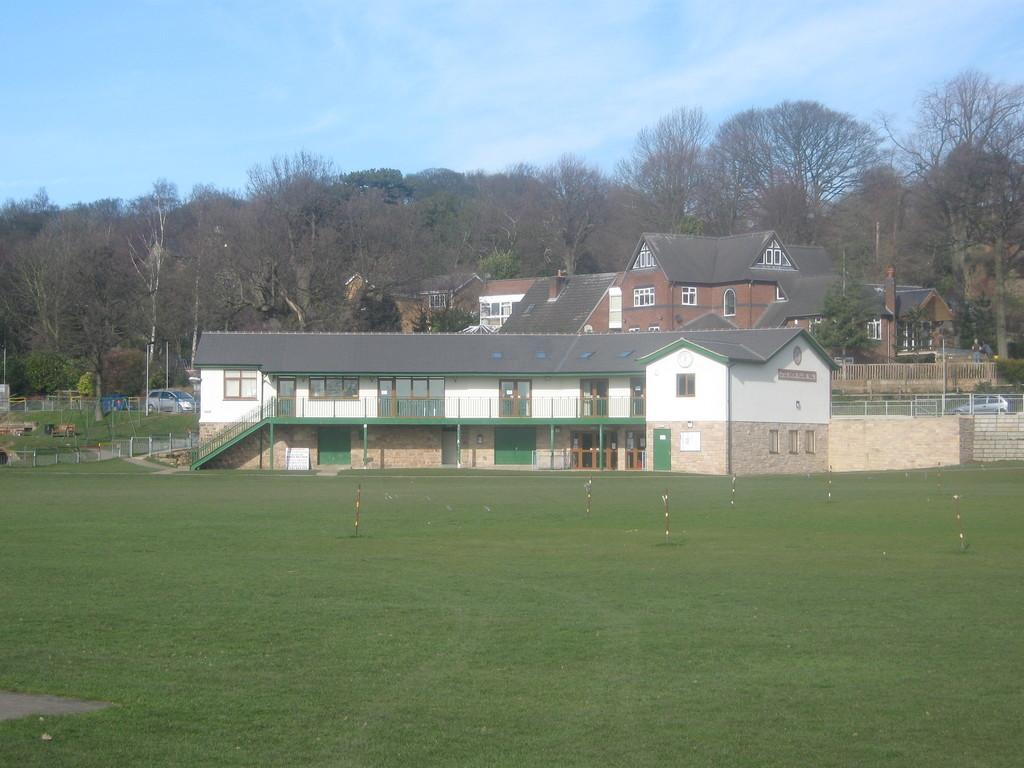What type of ground surface is visible in the image? There is grass on the ground in the image. What structures can be seen in the image? There are poles, buildings, and a railing visible in the image. What type of transportation is present in the image? There are vehicles in the image. What other natural elements can be seen in the image? There are trees in the image. What is visible in the background of the image? The sky is visible in the background of the image. How many loaves of bread are being used to act as a support for the trees in the image? There are no loaves of bread present in the image, and they are not being used to support the trees. What type of mice can be seen interacting with the vehicles in the image? There are no mice present in the image, and therefore no such interaction can be observed. 